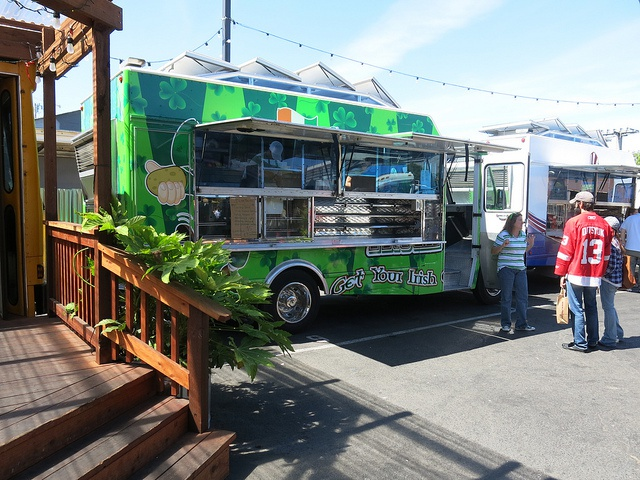Describe the objects in this image and their specific colors. I can see truck in lightblue, black, gray, darkgreen, and teal tones, truck in lightblue, white, gray, and darkgray tones, people in lightblue, white, salmon, black, and lightpink tones, people in lightblue, navy, black, gray, and blue tones, and people in lightblue, darkblue, gray, and navy tones in this image. 